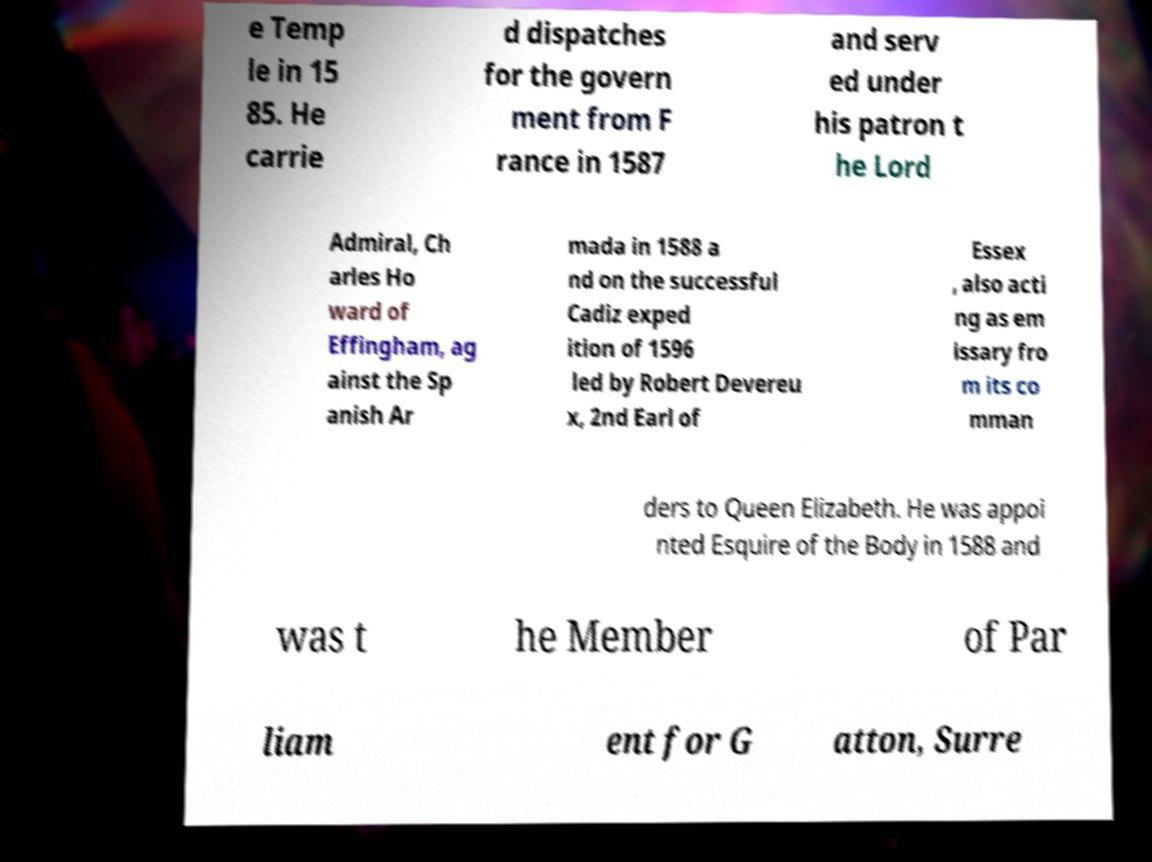I need the written content from this picture converted into text. Can you do that? e Temp le in 15 85. He carrie d dispatches for the govern ment from F rance in 1587 and serv ed under his patron t he Lord Admiral, Ch arles Ho ward of Effingham, ag ainst the Sp anish Ar mada in 1588 a nd on the successful Cadiz exped ition of 1596 led by Robert Devereu x, 2nd Earl of Essex , also acti ng as em issary fro m its co mman ders to Queen Elizabeth. He was appoi nted Esquire of the Body in 1588 and was t he Member of Par liam ent for G atton, Surre 